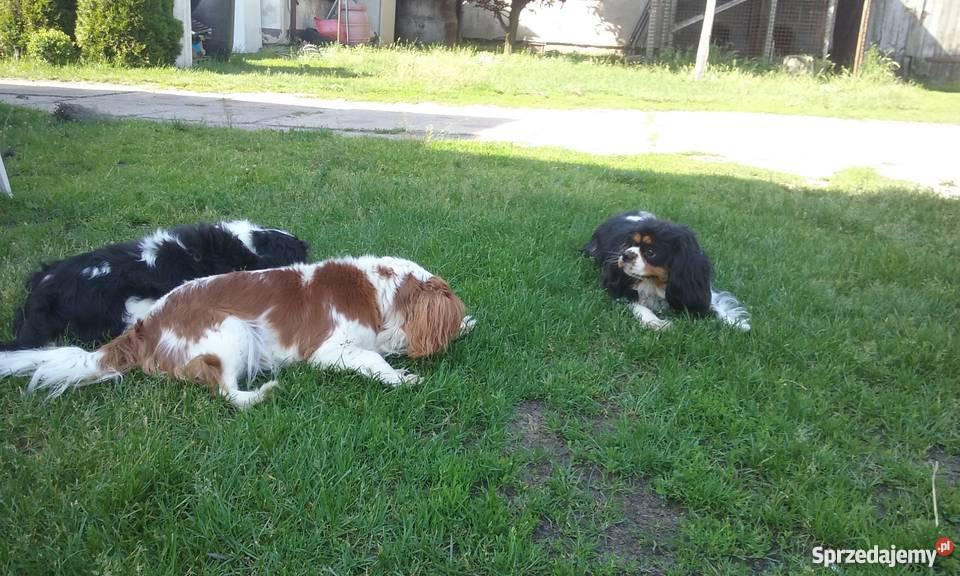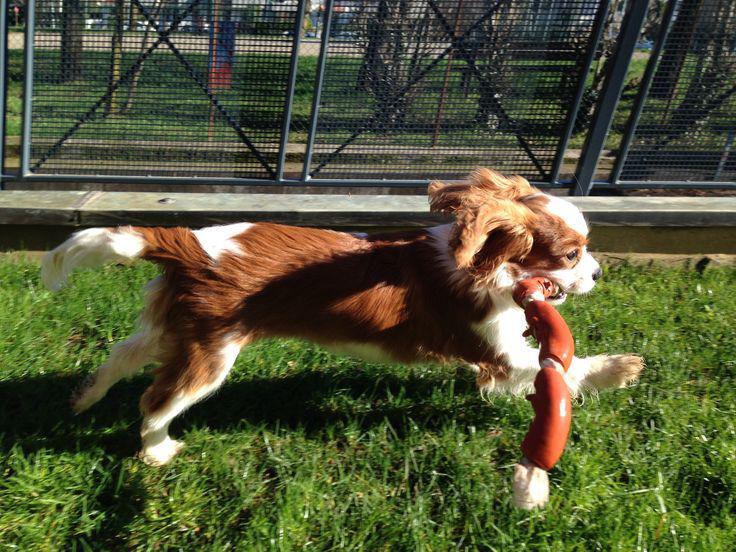The first image is the image on the left, the second image is the image on the right. Evaluate the accuracy of this statement regarding the images: "At least one of the dogs is not standing on grass.". Is it true? Answer yes or no. No. The first image is the image on the left, the second image is the image on the right. Examine the images to the left and right. Is the description "There are more spaniels with brown ears than spaniels with black ears." accurate? Answer yes or no. No. 